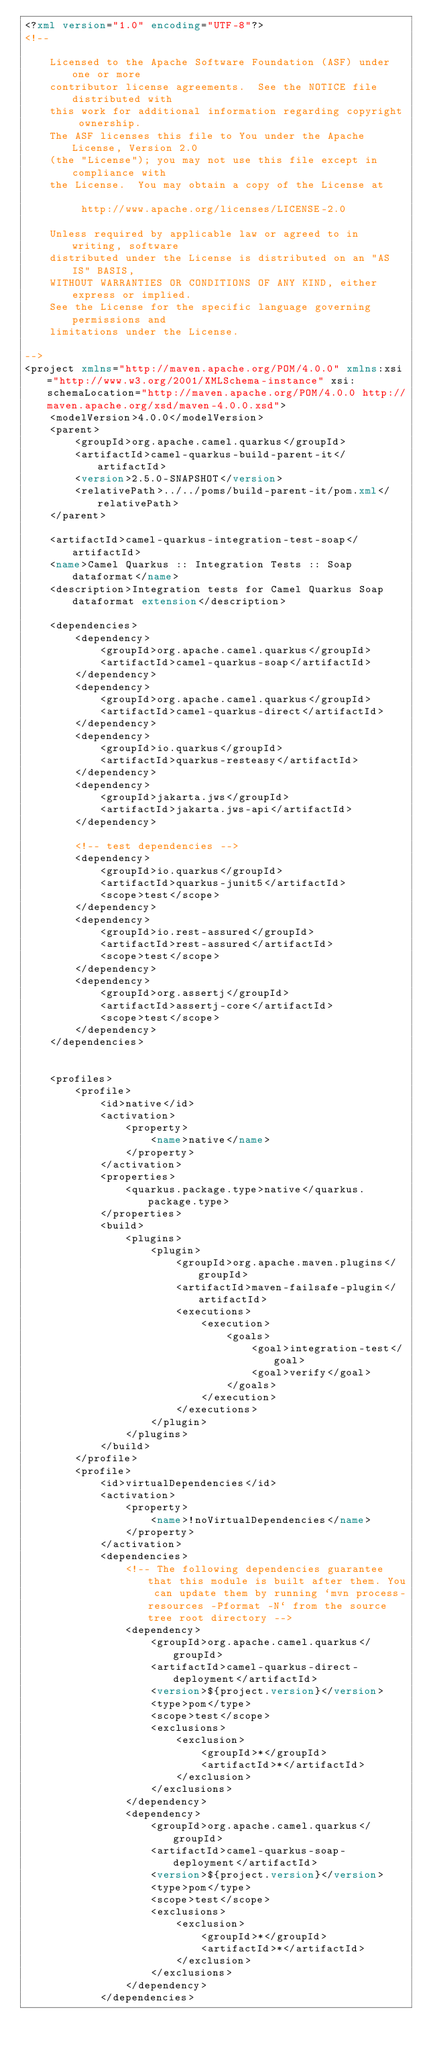<code> <loc_0><loc_0><loc_500><loc_500><_XML_><?xml version="1.0" encoding="UTF-8"?>
<!--

    Licensed to the Apache Software Foundation (ASF) under one or more
    contributor license agreements.  See the NOTICE file distributed with
    this work for additional information regarding copyright ownership.
    The ASF licenses this file to You under the Apache License, Version 2.0
    (the "License"); you may not use this file except in compliance with
    the License.  You may obtain a copy of the License at

         http://www.apache.org/licenses/LICENSE-2.0

    Unless required by applicable law or agreed to in writing, software
    distributed under the License is distributed on an "AS IS" BASIS,
    WITHOUT WARRANTIES OR CONDITIONS OF ANY KIND, either express or implied.
    See the License for the specific language governing permissions and
    limitations under the License.

-->
<project xmlns="http://maven.apache.org/POM/4.0.0" xmlns:xsi="http://www.w3.org/2001/XMLSchema-instance" xsi:schemaLocation="http://maven.apache.org/POM/4.0.0 http://maven.apache.org/xsd/maven-4.0.0.xsd">
    <modelVersion>4.0.0</modelVersion>
    <parent>
        <groupId>org.apache.camel.quarkus</groupId>
        <artifactId>camel-quarkus-build-parent-it</artifactId>
        <version>2.5.0-SNAPSHOT</version>
        <relativePath>../../poms/build-parent-it/pom.xml</relativePath>
    </parent>

    <artifactId>camel-quarkus-integration-test-soap</artifactId>
    <name>Camel Quarkus :: Integration Tests :: Soap dataformat</name>
    <description>Integration tests for Camel Quarkus Soap dataformat extension</description>

    <dependencies>
        <dependency>
            <groupId>org.apache.camel.quarkus</groupId>
            <artifactId>camel-quarkus-soap</artifactId>
        </dependency>
        <dependency>
            <groupId>org.apache.camel.quarkus</groupId>
            <artifactId>camel-quarkus-direct</artifactId>
        </dependency>
        <dependency>
            <groupId>io.quarkus</groupId>
            <artifactId>quarkus-resteasy</artifactId>
        </dependency>
        <dependency>
            <groupId>jakarta.jws</groupId>
            <artifactId>jakarta.jws-api</artifactId>
        </dependency>

        <!-- test dependencies -->
        <dependency>
            <groupId>io.quarkus</groupId>
            <artifactId>quarkus-junit5</artifactId>
            <scope>test</scope>
        </dependency>
        <dependency>
            <groupId>io.rest-assured</groupId>
            <artifactId>rest-assured</artifactId>
            <scope>test</scope>
        </dependency>
        <dependency>
            <groupId>org.assertj</groupId>
            <artifactId>assertj-core</artifactId>
            <scope>test</scope>
        </dependency>
    </dependencies>


    <profiles>
        <profile>
            <id>native</id>
            <activation>
                <property>
                    <name>native</name>
                </property>
            </activation>
            <properties>
                <quarkus.package.type>native</quarkus.package.type>
            </properties>
            <build>
                <plugins>
                    <plugin>
                        <groupId>org.apache.maven.plugins</groupId>
                        <artifactId>maven-failsafe-plugin</artifactId>
                        <executions>
                            <execution>
                                <goals>
                                    <goal>integration-test</goal>
                                    <goal>verify</goal>
                                </goals>
                            </execution>
                        </executions>
                    </plugin>
                </plugins>
            </build>
        </profile>
        <profile>
            <id>virtualDependencies</id>
            <activation>
                <property>
                    <name>!noVirtualDependencies</name>
                </property>
            </activation>
            <dependencies>
                <!-- The following dependencies guarantee that this module is built after them. You can update them by running `mvn process-resources -Pformat -N` from the source tree root directory -->
                <dependency>
                    <groupId>org.apache.camel.quarkus</groupId>
                    <artifactId>camel-quarkus-direct-deployment</artifactId>
                    <version>${project.version}</version>
                    <type>pom</type>
                    <scope>test</scope>
                    <exclusions>
                        <exclusion>
                            <groupId>*</groupId>
                            <artifactId>*</artifactId>
                        </exclusion>
                    </exclusions>
                </dependency>
                <dependency>
                    <groupId>org.apache.camel.quarkus</groupId>
                    <artifactId>camel-quarkus-soap-deployment</artifactId>
                    <version>${project.version}</version>
                    <type>pom</type>
                    <scope>test</scope>
                    <exclusions>
                        <exclusion>
                            <groupId>*</groupId>
                            <artifactId>*</artifactId>
                        </exclusion>
                    </exclusions>
                </dependency>
            </dependencies></code> 